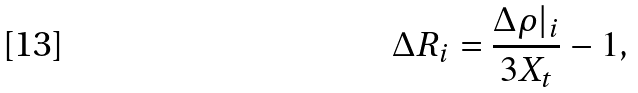<formula> <loc_0><loc_0><loc_500><loc_500>\Delta R _ { i } = \frac { \Delta \rho | _ { i } } { 3 X _ { t } } - 1 ,</formula> 